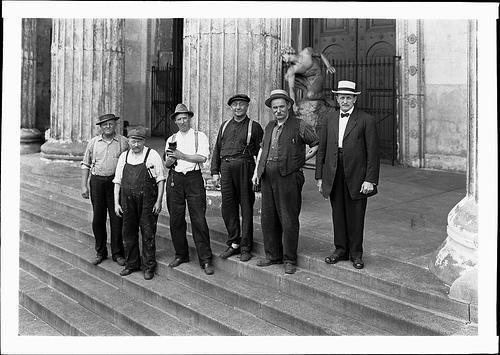How many men are there?
Give a very brief answer. 6. How many people are in the photo?
Give a very brief answer. 6. 